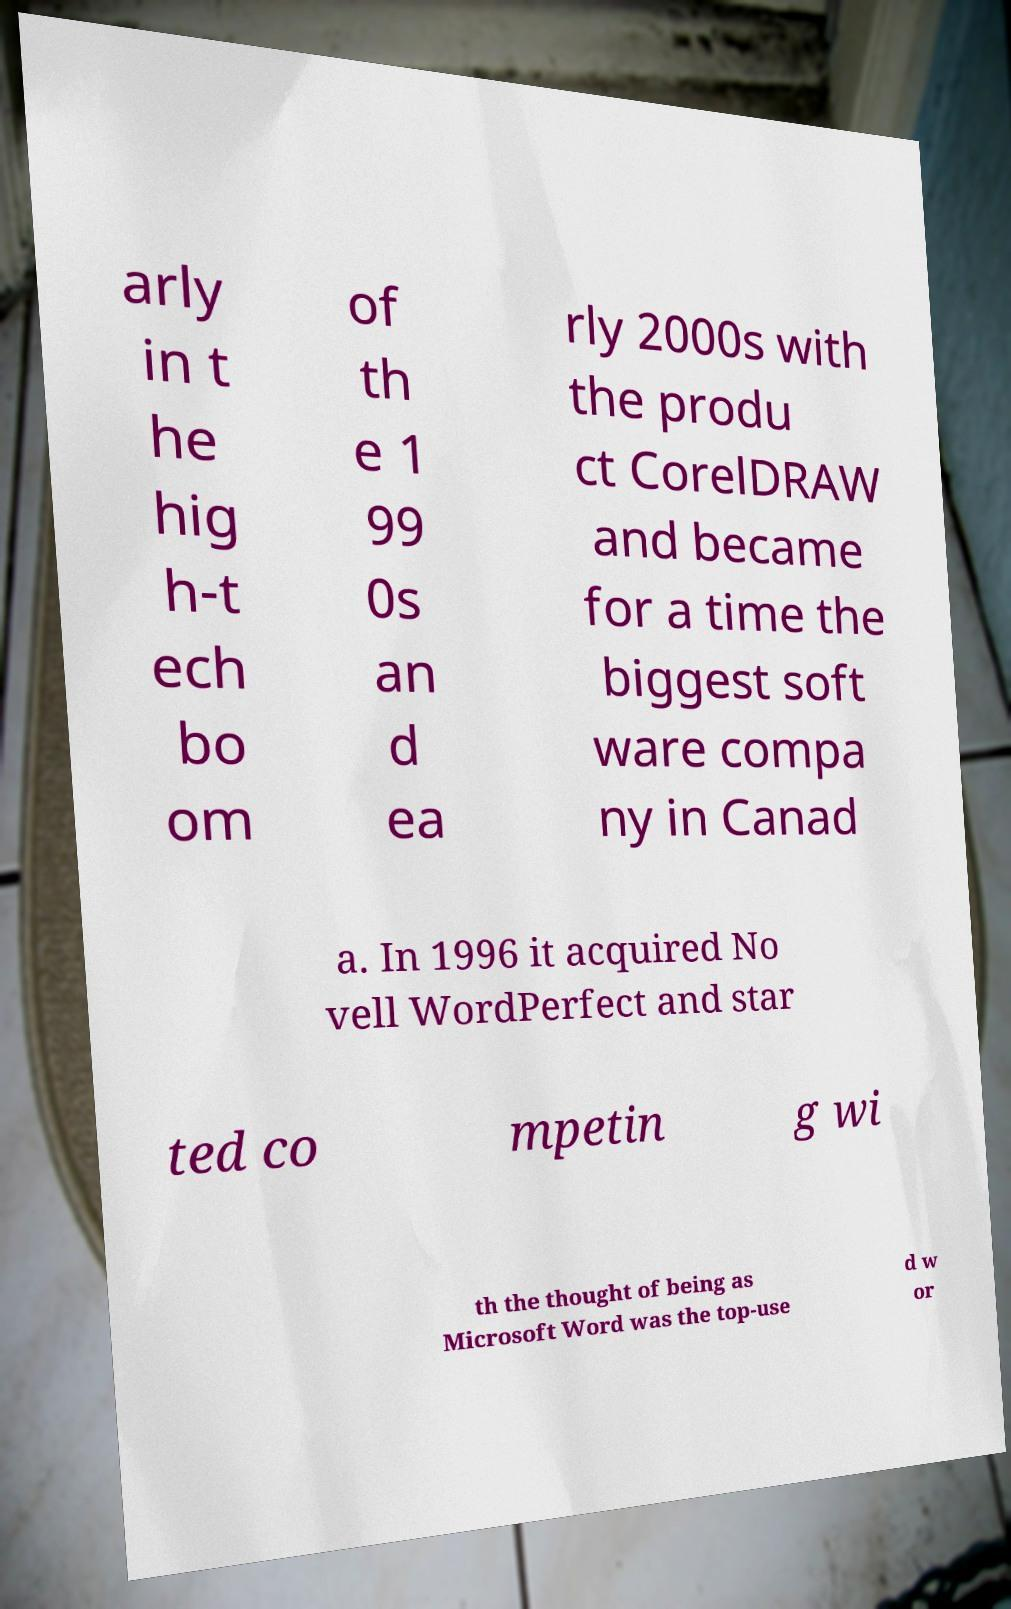There's text embedded in this image that I need extracted. Can you transcribe it verbatim? arly in t he hig h-t ech bo om of th e 1 99 0s an d ea rly 2000s with the produ ct CorelDRAW and became for a time the biggest soft ware compa ny in Canad a. In 1996 it acquired No vell WordPerfect and star ted co mpetin g wi th the thought of being as Microsoft Word was the top-use d w or 